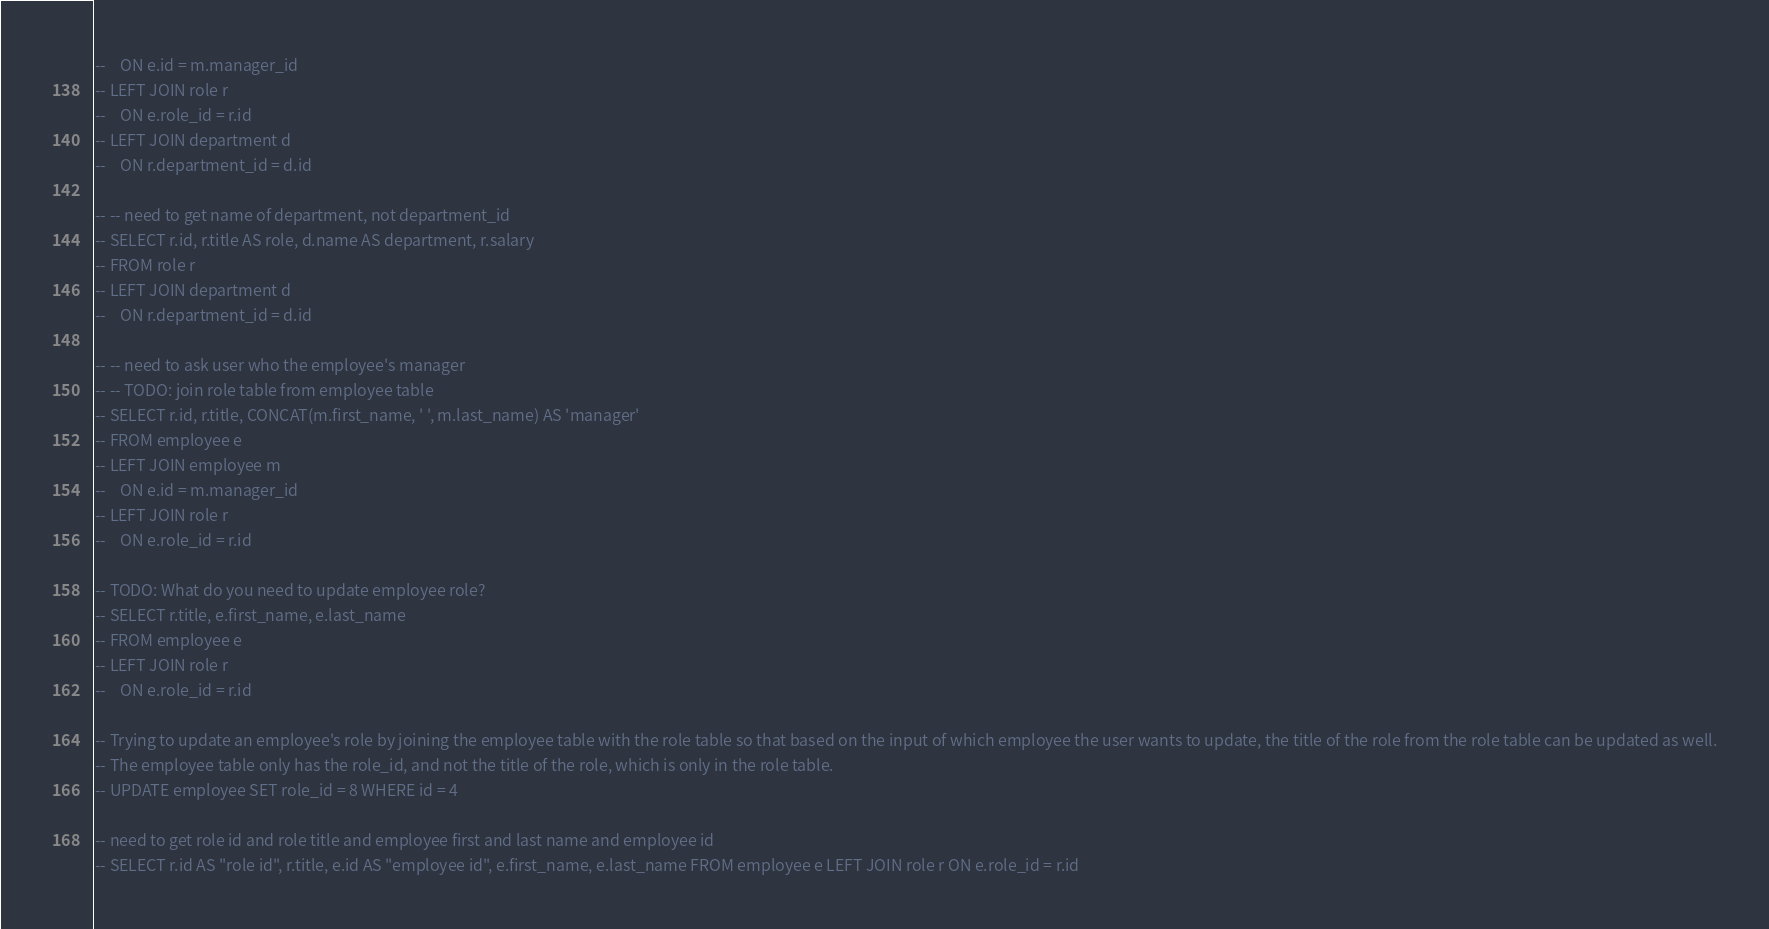<code> <loc_0><loc_0><loc_500><loc_500><_SQL_>--    ON e.id = m.manager_id
-- LEFT JOIN role r
--    ON e.role_id = r.id
-- LEFT JOIN department d 
--    ON r.department_id = d.id

-- -- need to get name of department, not department_id
-- SELECT r.id, r.title AS role, d.name AS department, r.salary 
-- FROM role r
-- LEFT JOIN department d
--    ON r.department_id = d.id

-- -- need to ask user who the employee's manager 
-- -- TODO: join role table from employee table 
-- SELECT r.id, r.title, CONCAT(m.first_name, ' ', m.last_name) AS 'manager' 
-- FROM employee e 
-- LEFT JOIN employee m 
--    ON e.id = m.manager_id 
-- LEFT JOIN role r 
--    ON e.role_id = r.id

-- TODO: What do you need to update employee role? 
-- SELECT r.title, e.first_name, e.last_name 
-- FROM employee e 
-- LEFT JOIN role r 
--    ON e.role_id = r.id

-- Trying to update an employee's role by joining the employee table with the role table so that based on the input of which employee the user wants to update, the title of the role from the role table can be updated as well.
-- The employee table only has the role_id, and not the title of the role, which is only in the role table.
-- UPDATE employee SET role_id = 8 WHERE id = 4

-- need to get role id and role title and employee first and last name and employee id
-- SELECT r.id AS "role id", r.title, e.id AS "employee id", e.first_name, e.last_name FROM employee e LEFT JOIN role r ON e.role_id = r.id</code> 